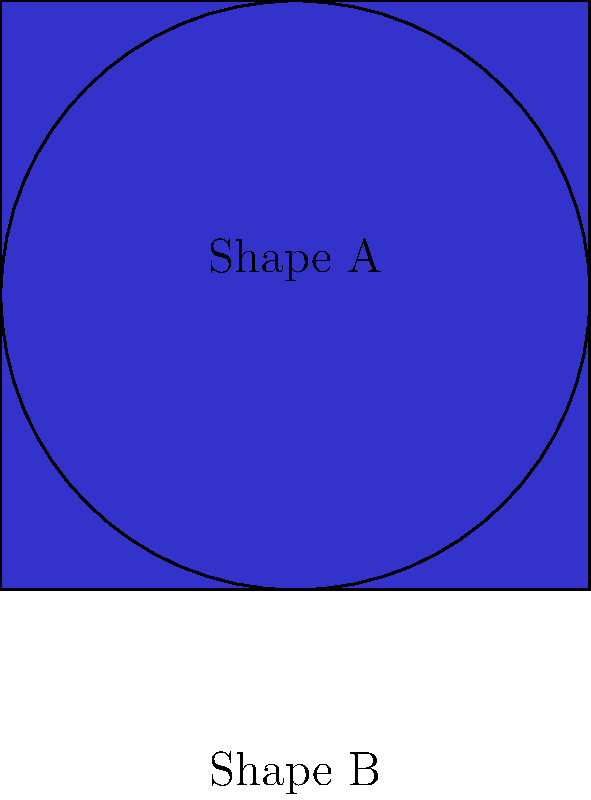Consider the two shapes shown above: a circle (Shape A) and a square (Shape B). As a teacher creating a lesson plan for a student undergoing treatment, you want to introduce the concept of homeomorphism. Explain why these two shapes are homeomorphic and provide an example of a continuous deformation that transforms one into the other. To explain why the circle and square are homeomorphic, we can follow these steps:

1. Definition: Two shapes are homeomorphic if there exists a continuous function that maps one shape onto the other, with a continuous inverse.

2. Intuitive understanding: Homeomorphic shapes can be continuously deformed into each other without cutting, tearing, or gluing.

3. Properties preserved: Homeomorphisms preserve topological properties such as connectedness and the number of holes.

4. Circle and square comparison:
   a) Both are simple closed curves in the plane.
   b) Both have no holes.
   c) Both are connected and have a continuous boundary.

5. Continuous deformation example:
   a) Start with the circle.
   b) Gradually push in four equidistant points on the circle's circumference.
   c) Continue pushing until these points form the corners of a square.
   d) Straighten the sides between the corners.

6. Inverse transformation:
   a) Start with the square.
   b) Gradually round off the corners.
   c) Continue smoothing until a perfect circle is formed.

7. Continuity: Both transformations (circle to square and square to circle) can be done without breaking the shape, ensuring continuity.

8. Bijection: Every point on the circle corresponds to a unique point on the square and vice versa.

Therefore, the circle and square are homeomorphic because they can be continuously deformed into each other while preserving their topological properties.
Answer: The circle and square are homeomorphic because they can be continuously deformed into each other without cutting or gluing, preserving topological properties. 